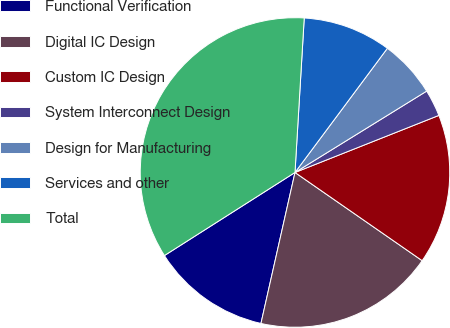<chart> <loc_0><loc_0><loc_500><loc_500><pie_chart><fcel>Functional Verification<fcel>Digital IC Design<fcel>Custom IC Design<fcel>System Interconnect Design<fcel>Design for Manufacturing<fcel>Services and other<fcel>Total<nl><fcel>12.45%<fcel>18.88%<fcel>15.66%<fcel>2.8%<fcel>6.01%<fcel>9.23%<fcel>34.97%<nl></chart> 